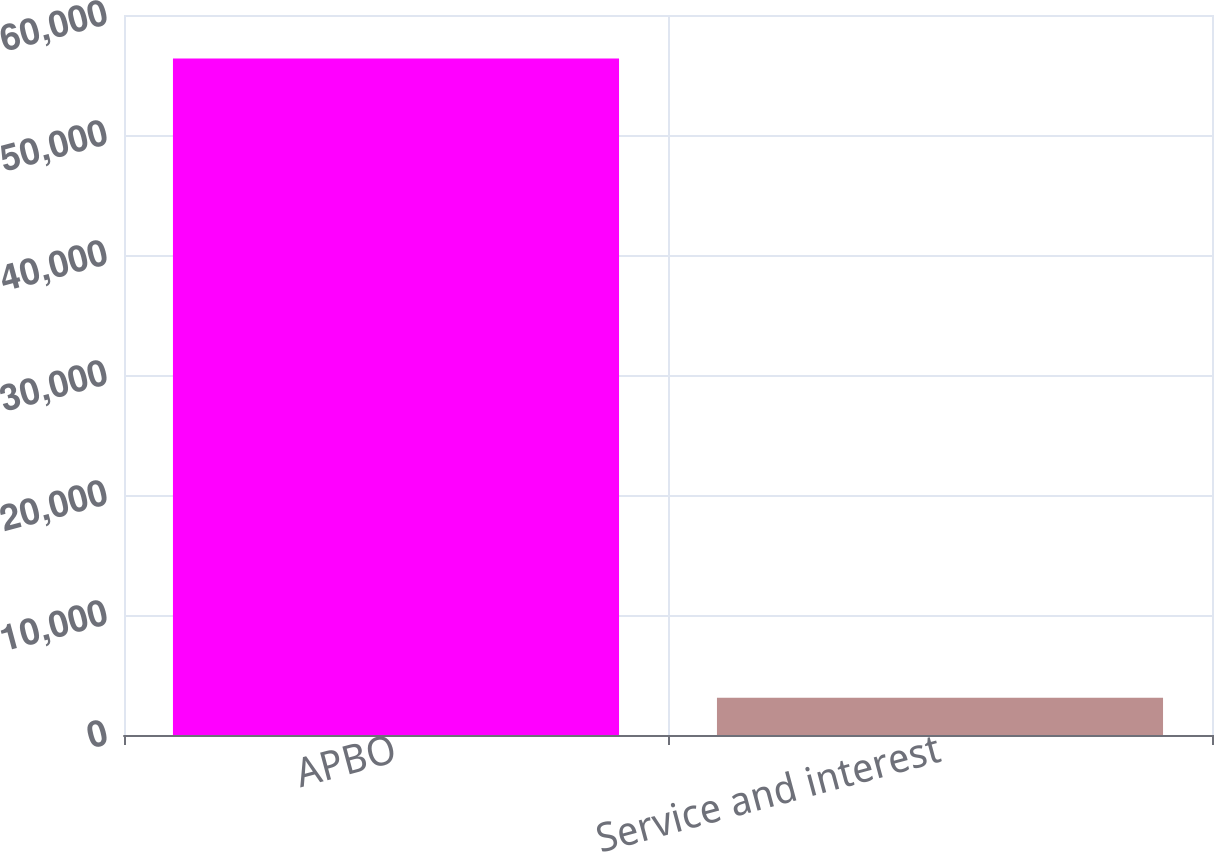Convert chart to OTSL. <chart><loc_0><loc_0><loc_500><loc_500><bar_chart><fcel>APBO<fcel>Service and interest<nl><fcel>56383<fcel>3113<nl></chart> 